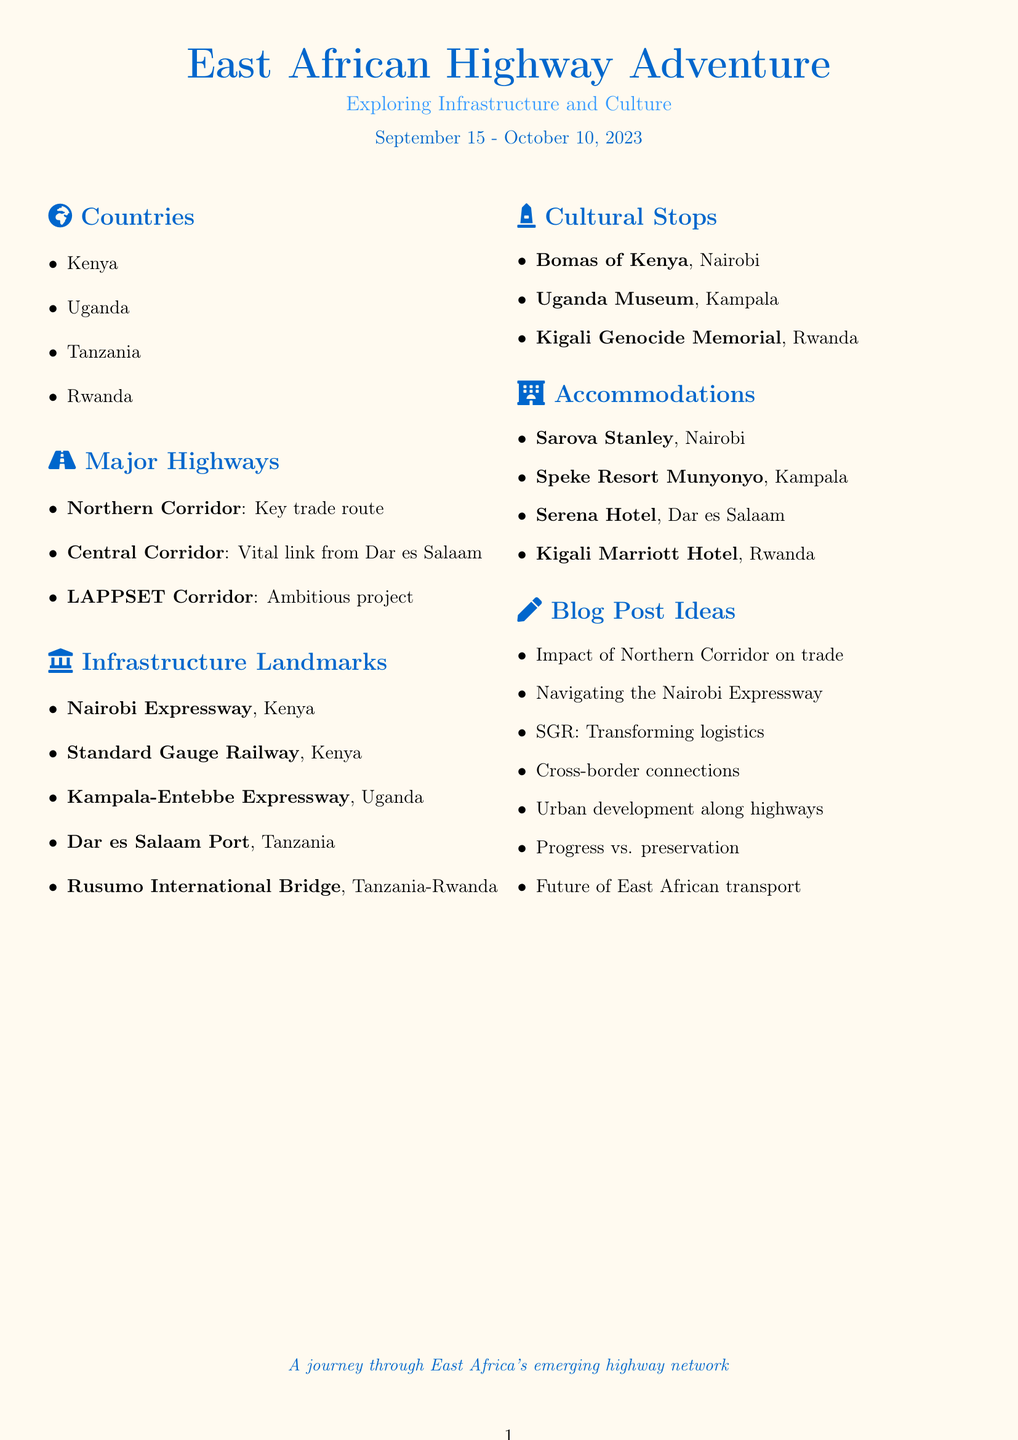What are the travel dates for the trip? The travel dates are specified as September 15 to October 10, 2023.
Answer: September 15 - October 10, 2023 Which country is associated with the Nairobi Expressway? The document states that the Nairobi Expressway is located in Nairobi, Kenya.
Answer: Kenya What is the length of the Kampala-Entebbe Expressway? The document mentions that the Kampala-Entebbe Expressway is 51km long.
Answer: 51km What major highway is described as a link from Tanzania's Dar es Salaam port? The document refers to the Central Corridor as the vital link from Dar es Salaam.
Answer: Central Corridor Name a cultural stop in Kigali, Rwanda. The document lists the Kigali Genocide Memorial as a cultural stop in Kigali.
Answer: Kigali Genocide Memorial What type of accommodation is Sarova Stanley? The document describes Sarova Stanley as a historic luxury hotel.
Answer: Historic luxury hotel How many major highways are listed in the document? There are three major highways mentioned: Northern Corridor, Central Corridor, and LAPPSET Corridor.
Answer: Three What is the significance of Rusumo International Bridge? The document states that it facilitates cross-border trade and movement between Tanzania and Rwanda.
Answer: Cross-border trade and movement What is one of the blog post ideas related to infrastructure? The document includes "The Impact of the Northern Corridor on East African Trade" as a blog post idea.
Answer: The Impact of the Northern Corridor on East African Trade 